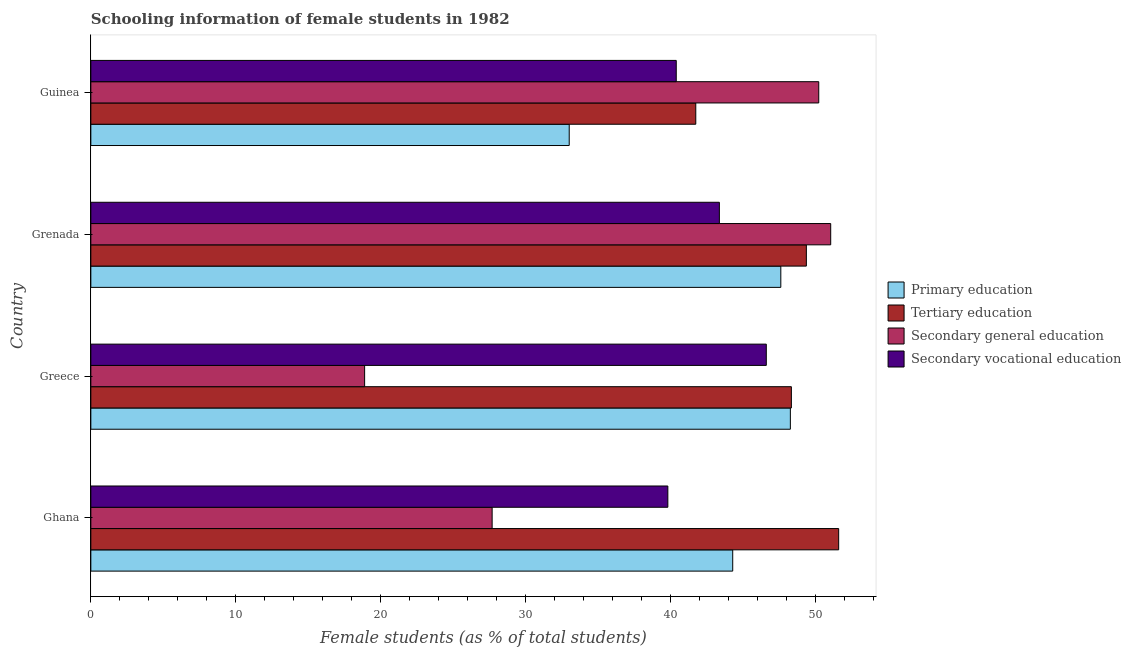Are the number of bars per tick equal to the number of legend labels?
Ensure brevity in your answer.  Yes. Are the number of bars on each tick of the Y-axis equal?
Ensure brevity in your answer.  Yes. How many bars are there on the 4th tick from the top?
Provide a short and direct response. 4. What is the label of the 4th group of bars from the top?
Offer a very short reply. Ghana. In how many cases, is the number of bars for a given country not equal to the number of legend labels?
Keep it short and to the point. 0. What is the percentage of female students in tertiary education in Grenada?
Offer a very short reply. 49.38. Across all countries, what is the maximum percentage of female students in primary education?
Provide a succinct answer. 48.28. Across all countries, what is the minimum percentage of female students in secondary education?
Offer a very short reply. 18.9. In which country was the percentage of female students in secondary education maximum?
Ensure brevity in your answer.  Grenada. What is the total percentage of female students in secondary vocational education in the graph?
Provide a short and direct response. 170.22. What is the difference between the percentage of female students in tertiary education in Greece and that in Guinea?
Your response must be concise. 6.6. What is the difference between the percentage of female students in primary education in Ghana and the percentage of female students in tertiary education in Greece?
Provide a short and direct response. -4.05. What is the average percentage of female students in secondary vocational education per country?
Provide a succinct answer. 42.55. What is the difference between the percentage of female students in tertiary education and percentage of female students in secondary vocational education in Guinea?
Give a very brief answer. 1.35. In how many countries, is the percentage of female students in primary education greater than 4 %?
Give a very brief answer. 4. What is the ratio of the percentage of female students in secondary vocational education in Ghana to that in Grenada?
Offer a very short reply. 0.92. What is the difference between the highest and the second highest percentage of female students in secondary vocational education?
Your response must be concise. 3.24. What is the difference between the highest and the lowest percentage of female students in secondary vocational education?
Keep it short and to the point. 6.79. What does the 2nd bar from the top in Ghana represents?
Your answer should be compact. Secondary general education. What does the 4th bar from the bottom in Greece represents?
Your answer should be compact. Secondary vocational education. How many countries are there in the graph?
Provide a short and direct response. 4. What is the difference between two consecutive major ticks on the X-axis?
Keep it short and to the point. 10. How are the legend labels stacked?
Keep it short and to the point. Vertical. What is the title of the graph?
Keep it short and to the point. Schooling information of female students in 1982. Does "Taxes on revenue" appear as one of the legend labels in the graph?
Offer a very short reply. No. What is the label or title of the X-axis?
Your answer should be compact. Female students (as % of total students). What is the Female students (as % of total students) in Primary education in Ghana?
Make the answer very short. 44.3. What is the Female students (as % of total students) of Tertiary education in Ghana?
Provide a short and direct response. 51.61. What is the Female students (as % of total students) of Secondary general education in Ghana?
Ensure brevity in your answer.  27.7. What is the Female students (as % of total students) in Secondary vocational education in Ghana?
Make the answer very short. 39.82. What is the Female students (as % of total students) in Primary education in Greece?
Offer a very short reply. 48.28. What is the Female students (as % of total students) in Tertiary education in Greece?
Ensure brevity in your answer.  48.35. What is the Female students (as % of total students) of Secondary general education in Greece?
Ensure brevity in your answer.  18.9. What is the Female students (as % of total students) in Secondary vocational education in Greece?
Your answer should be very brief. 46.62. What is the Female students (as % of total students) in Primary education in Grenada?
Offer a very short reply. 47.62. What is the Female students (as % of total students) in Tertiary education in Grenada?
Your answer should be very brief. 49.38. What is the Female students (as % of total students) in Secondary general education in Grenada?
Your response must be concise. 51.06. What is the Female students (as % of total students) of Secondary vocational education in Grenada?
Offer a very short reply. 43.38. What is the Female students (as % of total students) in Primary education in Guinea?
Provide a short and direct response. 33.02. What is the Female students (as % of total students) of Tertiary education in Guinea?
Your response must be concise. 41.75. What is the Female students (as % of total students) in Secondary general education in Guinea?
Offer a terse response. 50.24. What is the Female students (as % of total students) in Secondary vocational education in Guinea?
Give a very brief answer. 40.4. Across all countries, what is the maximum Female students (as % of total students) of Primary education?
Your answer should be compact. 48.28. Across all countries, what is the maximum Female students (as % of total students) in Tertiary education?
Ensure brevity in your answer.  51.61. Across all countries, what is the maximum Female students (as % of total students) of Secondary general education?
Offer a very short reply. 51.06. Across all countries, what is the maximum Female students (as % of total students) of Secondary vocational education?
Provide a short and direct response. 46.62. Across all countries, what is the minimum Female students (as % of total students) in Primary education?
Make the answer very short. 33.02. Across all countries, what is the minimum Female students (as % of total students) of Tertiary education?
Your answer should be compact. 41.75. Across all countries, what is the minimum Female students (as % of total students) of Secondary general education?
Make the answer very short. 18.9. Across all countries, what is the minimum Female students (as % of total students) in Secondary vocational education?
Your response must be concise. 39.82. What is the total Female students (as % of total students) of Primary education in the graph?
Provide a succinct answer. 173.21. What is the total Female students (as % of total students) in Tertiary education in the graph?
Offer a terse response. 191.09. What is the total Female students (as % of total students) in Secondary general education in the graph?
Offer a terse response. 147.89. What is the total Female students (as % of total students) in Secondary vocational education in the graph?
Keep it short and to the point. 170.22. What is the difference between the Female students (as % of total students) of Primary education in Ghana and that in Greece?
Offer a terse response. -3.98. What is the difference between the Female students (as % of total students) of Tertiary education in Ghana and that in Greece?
Keep it short and to the point. 3.26. What is the difference between the Female students (as % of total students) in Secondary vocational education in Ghana and that in Greece?
Your answer should be very brief. -6.79. What is the difference between the Female students (as % of total students) in Primary education in Ghana and that in Grenada?
Offer a very short reply. -3.32. What is the difference between the Female students (as % of total students) of Tertiary education in Ghana and that in Grenada?
Your response must be concise. 2.23. What is the difference between the Female students (as % of total students) of Secondary general education in Ghana and that in Grenada?
Give a very brief answer. -23.37. What is the difference between the Female students (as % of total students) in Secondary vocational education in Ghana and that in Grenada?
Provide a short and direct response. -3.56. What is the difference between the Female students (as % of total students) in Primary education in Ghana and that in Guinea?
Your answer should be very brief. 11.28. What is the difference between the Female students (as % of total students) of Tertiary education in Ghana and that in Guinea?
Offer a very short reply. 9.86. What is the difference between the Female students (as % of total students) of Secondary general education in Ghana and that in Guinea?
Provide a succinct answer. -22.54. What is the difference between the Female students (as % of total students) of Secondary vocational education in Ghana and that in Guinea?
Provide a short and direct response. -0.58. What is the difference between the Female students (as % of total students) in Primary education in Greece and that in Grenada?
Offer a terse response. 0.66. What is the difference between the Female students (as % of total students) of Tertiary education in Greece and that in Grenada?
Give a very brief answer. -1.03. What is the difference between the Female students (as % of total students) of Secondary general education in Greece and that in Grenada?
Keep it short and to the point. -32.17. What is the difference between the Female students (as % of total students) of Secondary vocational education in Greece and that in Grenada?
Offer a very short reply. 3.24. What is the difference between the Female students (as % of total students) in Primary education in Greece and that in Guinea?
Offer a very short reply. 15.26. What is the difference between the Female students (as % of total students) of Tertiary education in Greece and that in Guinea?
Ensure brevity in your answer.  6.6. What is the difference between the Female students (as % of total students) of Secondary general education in Greece and that in Guinea?
Provide a succinct answer. -31.34. What is the difference between the Female students (as % of total students) in Secondary vocational education in Greece and that in Guinea?
Provide a short and direct response. 6.22. What is the difference between the Female students (as % of total students) of Primary education in Grenada and that in Guinea?
Provide a succinct answer. 14.6. What is the difference between the Female students (as % of total students) of Tertiary education in Grenada and that in Guinea?
Keep it short and to the point. 7.63. What is the difference between the Female students (as % of total students) of Secondary general education in Grenada and that in Guinea?
Offer a terse response. 0.82. What is the difference between the Female students (as % of total students) in Secondary vocational education in Grenada and that in Guinea?
Offer a terse response. 2.98. What is the difference between the Female students (as % of total students) of Primary education in Ghana and the Female students (as % of total students) of Tertiary education in Greece?
Keep it short and to the point. -4.05. What is the difference between the Female students (as % of total students) of Primary education in Ghana and the Female students (as % of total students) of Secondary general education in Greece?
Your answer should be very brief. 25.4. What is the difference between the Female students (as % of total students) in Primary education in Ghana and the Female students (as % of total students) in Secondary vocational education in Greece?
Provide a succinct answer. -2.32. What is the difference between the Female students (as % of total students) in Tertiary education in Ghana and the Female students (as % of total students) in Secondary general education in Greece?
Ensure brevity in your answer.  32.72. What is the difference between the Female students (as % of total students) of Tertiary education in Ghana and the Female students (as % of total students) of Secondary vocational education in Greece?
Keep it short and to the point. 5. What is the difference between the Female students (as % of total students) in Secondary general education in Ghana and the Female students (as % of total students) in Secondary vocational education in Greece?
Make the answer very short. -18.92. What is the difference between the Female students (as % of total students) of Primary education in Ghana and the Female students (as % of total students) of Tertiary education in Grenada?
Offer a terse response. -5.08. What is the difference between the Female students (as % of total students) in Primary education in Ghana and the Female students (as % of total students) in Secondary general education in Grenada?
Provide a succinct answer. -6.76. What is the difference between the Female students (as % of total students) in Primary education in Ghana and the Female students (as % of total students) in Secondary vocational education in Grenada?
Give a very brief answer. 0.92. What is the difference between the Female students (as % of total students) of Tertiary education in Ghana and the Female students (as % of total students) of Secondary general education in Grenada?
Offer a terse response. 0.55. What is the difference between the Female students (as % of total students) in Tertiary education in Ghana and the Female students (as % of total students) in Secondary vocational education in Grenada?
Give a very brief answer. 8.23. What is the difference between the Female students (as % of total students) in Secondary general education in Ghana and the Female students (as % of total students) in Secondary vocational education in Grenada?
Give a very brief answer. -15.68. What is the difference between the Female students (as % of total students) of Primary education in Ghana and the Female students (as % of total students) of Tertiary education in Guinea?
Give a very brief answer. 2.55. What is the difference between the Female students (as % of total students) of Primary education in Ghana and the Female students (as % of total students) of Secondary general education in Guinea?
Provide a short and direct response. -5.94. What is the difference between the Female students (as % of total students) in Primary education in Ghana and the Female students (as % of total students) in Secondary vocational education in Guinea?
Provide a short and direct response. 3.9. What is the difference between the Female students (as % of total students) of Tertiary education in Ghana and the Female students (as % of total students) of Secondary general education in Guinea?
Offer a terse response. 1.38. What is the difference between the Female students (as % of total students) of Tertiary education in Ghana and the Female students (as % of total students) of Secondary vocational education in Guinea?
Give a very brief answer. 11.21. What is the difference between the Female students (as % of total students) in Secondary general education in Ghana and the Female students (as % of total students) in Secondary vocational education in Guinea?
Offer a very short reply. -12.71. What is the difference between the Female students (as % of total students) in Primary education in Greece and the Female students (as % of total students) in Tertiary education in Grenada?
Your answer should be very brief. -1.1. What is the difference between the Female students (as % of total students) of Primary education in Greece and the Female students (as % of total students) of Secondary general education in Grenada?
Give a very brief answer. -2.78. What is the difference between the Female students (as % of total students) of Primary education in Greece and the Female students (as % of total students) of Secondary vocational education in Grenada?
Ensure brevity in your answer.  4.9. What is the difference between the Female students (as % of total students) in Tertiary education in Greece and the Female students (as % of total students) in Secondary general education in Grenada?
Your response must be concise. -2.71. What is the difference between the Female students (as % of total students) of Tertiary education in Greece and the Female students (as % of total students) of Secondary vocational education in Grenada?
Ensure brevity in your answer.  4.97. What is the difference between the Female students (as % of total students) in Secondary general education in Greece and the Female students (as % of total students) in Secondary vocational education in Grenada?
Your answer should be compact. -24.48. What is the difference between the Female students (as % of total students) in Primary education in Greece and the Female students (as % of total students) in Tertiary education in Guinea?
Offer a terse response. 6.53. What is the difference between the Female students (as % of total students) of Primary education in Greece and the Female students (as % of total students) of Secondary general education in Guinea?
Your answer should be very brief. -1.96. What is the difference between the Female students (as % of total students) of Primary education in Greece and the Female students (as % of total students) of Secondary vocational education in Guinea?
Keep it short and to the point. 7.88. What is the difference between the Female students (as % of total students) of Tertiary education in Greece and the Female students (as % of total students) of Secondary general education in Guinea?
Your answer should be very brief. -1.89. What is the difference between the Female students (as % of total students) in Tertiary education in Greece and the Female students (as % of total students) in Secondary vocational education in Guinea?
Offer a very short reply. 7.95. What is the difference between the Female students (as % of total students) in Secondary general education in Greece and the Female students (as % of total students) in Secondary vocational education in Guinea?
Your response must be concise. -21.51. What is the difference between the Female students (as % of total students) of Primary education in Grenada and the Female students (as % of total students) of Tertiary education in Guinea?
Your answer should be compact. 5.87. What is the difference between the Female students (as % of total students) of Primary education in Grenada and the Female students (as % of total students) of Secondary general education in Guinea?
Provide a short and direct response. -2.62. What is the difference between the Female students (as % of total students) of Primary education in Grenada and the Female students (as % of total students) of Secondary vocational education in Guinea?
Your response must be concise. 7.22. What is the difference between the Female students (as % of total students) in Tertiary education in Grenada and the Female students (as % of total students) in Secondary general education in Guinea?
Your answer should be very brief. -0.85. What is the difference between the Female students (as % of total students) in Tertiary education in Grenada and the Female students (as % of total students) in Secondary vocational education in Guinea?
Offer a terse response. 8.98. What is the difference between the Female students (as % of total students) in Secondary general education in Grenada and the Female students (as % of total students) in Secondary vocational education in Guinea?
Offer a terse response. 10.66. What is the average Female students (as % of total students) of Primary education per country?
Give a very brief answer. 43.3. What is the average Female students (as % of total students) of Tertiary education per country?
Your answer should be very brief. 47.77. What is the average Female students (as % of total students) of Secondary general education per country?
Offer a terse response. 36.97. What is the average Female students (as % of total students) in Secondary vocational education per country?
Offer a very short reply. 42.56. What is the difference between the Female students (as % of total students) in Primary education and Female students (as % of total students) in Tertiary education in Ghana?
Provide a short and direct response. -7.31. What is the difference between the Female students (as % of total students) of Primary education and Female students (as % of total students) of Secondary general education in Ghana?
Provide a short and direct response. 16.6. What is the difference between the Female students (as % of total students) of Primary education and Female students (as % of total students) of Secondary vocational education in Ghana?
Offer a very short reply. 4.48. What is the difference between the Female students (as % of total students) in Tertiary education and Female students (as % of total students) in Secondary general education in Ghana?
Make the answer very short. 23.92. What is the difference between the Female students (as % of total students) of Tertiary education and Female students (as % of total students) of Secondary vocational education in Ghana?
Give a very brief answer. 11.79. What is the difference between the Female students (as % of total students) in Secondary general education and Female students (as % of total students) in Secondary vocational education in Ghana?
Offer a very short reply. -12.13. What is the difference between the Female students (as % of total students) of Primary education and Female students (as % of total students) of Tertiary education in Greece?
Ensure brevity in your answer.  -0.07. What is the difference between the Female students (as % of total students) in Primary education and Female students (as % of total students) in Secondary general education in Greece?
Provide a succinct answer. 29.38. What is the difference between the Female students (as % of total students) in Primary education and Female students (as % of total students) in Secondary vocational education in Greece?
Your answer should be compact. 1.66. What is the difference between the Female students (as % of total students) of Tertiary education and Female students (as % of total students) of Secondary general education in Greece?
Offer a very short reply. 29.45. What is the difference between the Female students (as % of total students) in Tertiary education and Female students (as % of total students) in Secondary vocational education in Greece?
Your answer should be compact. 1.73. What is the difference between the Female students (as % of total students) of Secondary general education and Female students (as % of total students) of Secondary vocational education in Greece?
Provide a short and direct response. -27.72. What is the difference between the Female students (as % of total students) in Primary education and Female students (as % of total students) in Tertiary education in Grenada?
Offer a terse response. -1.76. What is the difference between the Female students (as % of total students) of Primary education and Female students (as % of total students) of Secondary general education in Grenada?
Offer a very short reply. -3.44. What is the difference between the Female students (as % of total students) in Primary education and Female students (as % of total students) in Secondary vocational education in Grenada?
Provide a short and direct response. 4.24. What is the difference between the Female students (as % of total students) in Tertiary education and Female students (as % of total students) in Secondary general education in Grenada?
Keep it short and to the point. -1.68. What is the difference between the Female students (as % of total students) of Tertiary education and Female students (as % of total students) of Secondary vocational education in Grenada?
Your answer should be very brief. 6. What is the difference between the Female students (as % of total students) of Secondary general education and Female students (as % of total students) of Secondary vocational education in Grenada?
Give a very brief answer. 7.68. What is the difference between the Female students (as % of total students) of Primary education and Female students (as % of total students) of Tertiary education in Guinea?
Provide a short and direct response. -8.74. What is the difference between the Female students (as % of total students) in Primary education and Female students (as % of total students) in Secondary general education in Guinea?
Your response must be concise. -17.22. What is the difference between the Female students (as % of total students) of Primary education and Female students (as % of total students) of Secondary vocational education in Guinea?
Offer a very short reply. -7.39. What is the difference between the Female students (as % of total students) of Tertiary education and Female students (as % of total students) of Secondary general education in Guinea?
Make the answer very short. -8.49. What is the difference between the Female students (as % of total students) in Tertiary education and Female students (as % of total students) in Secondary vocational education in Guinea?
Offer a terse response. 1.35. What is the difference between the Female students (as % of total students) in Secondary general education and Female students (as % of total students) in Secondary vocational education in Guinea?
Provide a succinct answer. 9.83. What is the ratio of the Female students (as % of total students) of Primary education in Ghana to that in Greece?
Offer a very short reply. 0.92. What is the ratio of the Female students (as % of total students) of Tertiary education in Ghana to that in Greece?
Ensure brevity in your answer.  1.07. What is the ratio of the Female students (as % of total students) in Secondary general education in Ghana to that in Greece?
Offer a very short reply. 1.47. What is the ratio of the Female students (as % of total students) of Secondary vocational education in Ghana to that in Greece?
Your answer should be compact. 0.85. What is the ratio of the Female students (as % of total students) of Primary education in Ghana to that in Grenada?
Your response must be concise. 0.93. What is the ratio of the Female students (as % of total students) of Tertiary education in Ghana to that in Grenada?
Keep it short and to the point. 1.05. What is the ratio of the Female students (as % of total students) of Secondary general education in Ghana to that in Grenada?
Ensure brevity in your answer.  0.54. What is the ratio of the Female students (as % of total students) in Secondary vocational education in Ghana to that in Grenada?
Keep it short and to the point. 0.92. What is the ratio of the Female students (as % of total students) in Primary education in Ghana to that in Guinea?
Give a very brief answer. 1.34. What is the ratio of the Female students (as % of total students) in Tertiary education in Ghana to that in Guinea?
Your response must be concise. 1.24. What is the ratio of the Female students (as % of total students) of Secondary general education in Ghana to that in Guinea?
Ensure brevity in your answer.  0.55. What is the ratio of the Female students (as % of total students) in Secondary vocational education in Ghana to that in Guinea?
Keep it short and to the point. 0.99. What is the ratio of the Female students (as % of total students) in Primary education in Greece to that in Grenada?
Make the answer very short. 1.01. What is the ratio of the Female students (as % of total students) in Tertiary education in Greece to that in Grenada?
Make the answer very short. 0.98. What is the ratio of the Female students (as % of total students) in Secondary general education in Greece to that in Grenada?
Your response must be concise. 0.37. What is the ratio of the Female students (as % of total students) in Secondary vocational education in Greece to that in Grenada?
Keep it short and to the point. 1.07. What is the ratio of the Female students (as % of total students) of Primary education in Greece to that in Guinea?
Give a very brief answer. 1.46. What is the ratio of the Female students (as % of total students) of Tertiary education in Greece to that in Guinea?
Keep it short and to the point. 1.16. What is the ratio of the Female students (as % of total students) of Secondary general education in Greece to that in Guinea?
Offer a terse response. 0.38. What is the ratio of the Female students (as % of total students) of Secondary vocational education in Greece to that in Guinea?
Make the answer very short. 1.15. What is the ratio of the Female students (as % of total students) in Primary education in Grenada to that in Guinea?
Your answer should be very brief. 1.44. What is the ratio of the Female students (as % of total students) in Tertiary education in Grenada to that in Guinea?
Your answer should be very brief. 1.18. What is the ratio of the Female students (as % of total students) in Secondary general education in Grenada to that in Guinea?
Offer a terse response. 1.02. What is the ratio of the Female students (as % of total students) of Secondary vocational education in Grenada to that in Guinea?
Make the answer very short. 1.07. What is the difference between the highest and the second highest Female students (as % of total students) of Primary education?
Give a very brief answer. 0.66. What is the difference between the highest and the second highest Female students (as % of total students) of Tertiary education?
Provide a short and direct response. 2.23. What is the difference between the highest and the second highest Female students (as % of total students) of Secondary general education?
Make the answer very short. 0.82. What is the difference between the highest and the second highest Female students (as % of total students) of Secondary vocational education?
Provide a succinct answer. 3.24. What is the difference between the highest and the lowest Female students (as % of total students) in Primary education?
Provide a succinct answer. 15.26. What is the difference between the highest and the lowest Female students (as % of total students) in Tertiary education?
Provide a short and direct response. 9.86. What is the difference between the highest and the lowest Female students (as % of total students) in Secondary general education?
Make the answer very short. 32.17. What is the difference between the highest and the lowest Female students (as % of total students) in Secondary vocational education?
Provide a succinct answer. 6.79. 